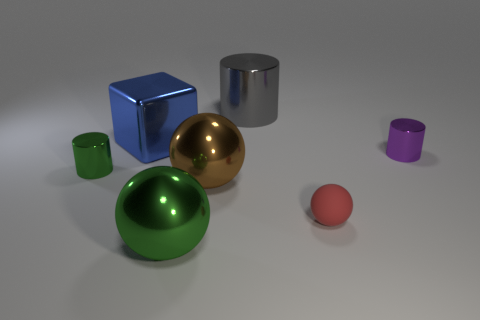What is the spatial arrangement of the objects in relation to each other? The objects are arranged with the blue cube, silver cylinder, and gold sphere forming a triangle near the center. The green sphere and green cylinder are closer to the front, and the purple cylinder is off to the right side. The red sphere is positioned in the foreground, separated from the rest. 